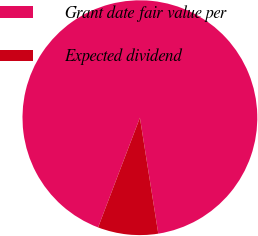<chart> <loc_0><loc_0><loc_500><loc_500><pie_chart><fcel>Grant date fair value per<fcel>Expected dividend<nl><fcel>91.7%<fcel>8.3%<nl></chart> 